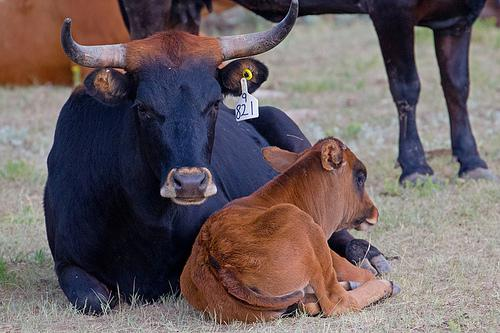Question: what do you see in this picture?
Choices:
A. 500 cats.
B. A big dog.
C. Some wheat.
D. A mother and calf.
Answer with the letter. Answer: D Question: what color is the calf?
Choices:
A. Brown.
B. Black.
C. Tan.
D. Beige.
Answer with the letter. Answer: A Question: where was this taken?
Choices:
A. In the snow.
B. Outer space.
C. A kitchen.
D. A farm.
Answer with the letter. Answer: D Question: who took this picture?
Choices:
A. A photographer.
B. The old guy.
C. Someone's enemy.
D. A celebrity.
Answer with the letter. Answer: A 